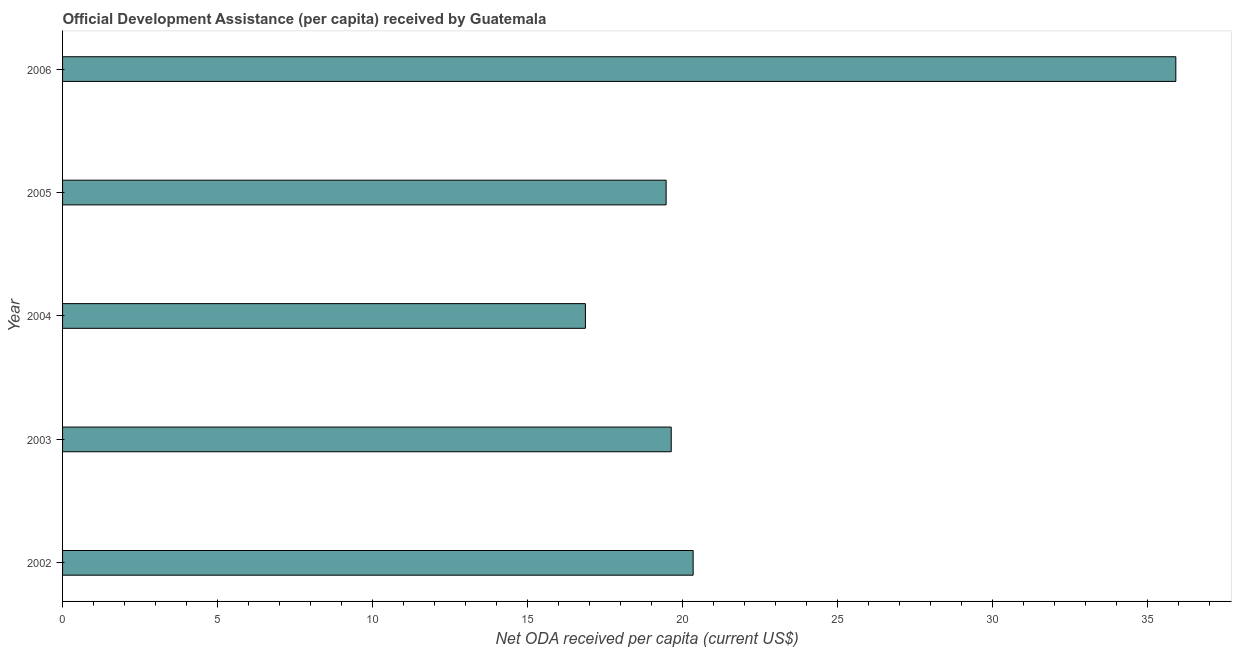Does the graph contain any zero values?
Provide a succinct answer. No. Does the graph contain grids?
Provide a succinct answer. No. What is the title of the graph?
Provide a short and direct response. Official Development Assistance (per capita) received by Guatemala. What is the label or title of the X-axis?
Give a very brief answer. Net ODA received per capita (current US$). What is the net oda received per capita in 2003?
Offer a terse response. 19.63. Across all years, what is the maximum net oda received per capita?
Make the answer very short. 35.9. Across all years, what is the minimum net oda received per capita?
Provide a succinct answer. 16.86. In which year was the net oda received per capita maximum?
Provide a short and direct response. 2006. What is the sum of the net oda received per capita?
Provide a short and direct response. 112.18. What is the difference between the net oda received per capita in 2002 and 2005?
Provide a short and direct response. 0.87. What is the average net oda received per capita per year?
Your answer should be very brief. 22.44. What is the median net oda received per capita?
Make the answer very short. 19.63. In how many years, is the net oda received per capita greater than 13 US$?
Provide a succinct answer. 5. Do a majority of the years between 2002 and 2006 (inclusive) have net oda received per capita greater than 23 US$?
Make the answer very short. No. What is the ratio of the net oda received per capita in 2002 to that in 2004?
Make the answer very short. 1.21. Is the difference between the net oda received per capita in 2002 and 2004 greater than the difference between any two years?
Keep it short and to the point. No. What is the difference between the highest and the second highest net oda received per capita?
Your answer should be compact. 15.56. What is the difference between the highest and the lowest net oda received per capita?
Ensure brevity in your answer.  19.04. How many years are there in the graph?
Ensure brevity in your answer.  5. Are the values on the major ticks of X-axis written in scientific E-notation?
Keep it short and to the point. No. What is the Net ODA received per capita (current US$) in 2002?
Give a very brief answer. 20.33. What is the Net ODA received per capita (current US$) in 2003?
Offer a very short reply. 19.63. What is the Net ODA received per capita (current US$) of 2004?
Offer a very short reply. 16.86. What is the Net ODA received per capita (current US$) of 2005?
Provide a short and direct response. 19.46. What is the Net ODA received per capita (current US$) in 2006?
Your answer should be very brief. 35.9. What is the difference between the Net ODA received per capita (current US$) in 2002 and 2003?
Offer a terse response. 0.71. What is the difference between the Net ODA received per capita (current US$) in 2002 and 2004?
Offer a terse response. 3.47. What is the difference between the Net ODA received per capita (current US$) in 2002 and 2005?
Keep it short and to the point. 0.87. What is the difference between the Net ODA received per capita (current US$) in 2002 and 2006?
Your answer should be very brief. -15.57. What is the difference between the Net ODA received per capita (current US$) in 2003 and 2004?
Keep it short and to the point. 2.77. What is the difference between the Net ODA received per capita (current US$) in 2003 and 2005?
Your answer should be very brief. 0.16. What is the difference between the Net ODA received per capita (current US$) in 2003 and 2006?
Keep it short and to the point. -16.27. What is the difference between the Net ODA received per capita (current US$) in 2004 and 2005?
Provide a succinct answer. -2.6. What is the difference between the Net ODA received per capita (current US$) in 2004 and 2006?
Your answer should be very brief. -19.04. What is the difference between the Net ODA received per capita (current US$) in 2005 and 2006?
Provide a succinct answer. -16.44. What is the ratio of the Net ODA received per capita (current US$) in 2002 to that in 2003?
Provide a short and direct response. 1.04. What is the ratio of the Net ODA received per capita (current US$) in 2002 to that in 2004?
Ensure brevity in your answer.  1.21. What is the ratio of the Net ODA received per capita (current US$) in 2002 to that in 2005?
Your response must be concise. 1.04. What is the ratio of the Net ODA received per capita (current US$) in 2002 to that in 2006?
Ensure brevity in your answer.  0.57. What is the ratio of the Net ODA received per capita (current US$) in 2003 to that in 2004?
Offer a terse response. 1.16. What is the ratio of the Net ODA received per capita (current US$) in 2003 to that in 2006?
Your answer should be compact. 0.55. What is the ratio of the Net ODA received per capita (current US$) in 2004 to that in 2005?
Provide a short and direct response. 0.87. What is the ratio of the Net ODA received per capita (current US$) in 2004 to that in 2006?
Give a very brief answer. 0.47. What is the ratio of the Net ODA received per capita (current US$) in 2005 to that in 2006?
Ensure brevity in your answer.  0.54. 